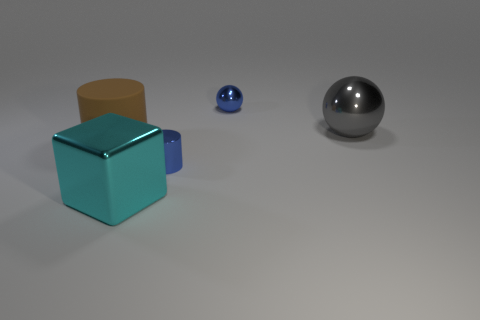Are any yellow metallic spheres visible?
Make the answer very short. No. What number of small objects are either cyan metal things or spheres?
Give a very brief answer. 1. Are there more tiny blue shiny cylinders to the left of the small blue shiny cylinder than large brown matte things that are behind the gray metallic sphere?
Make the answer very short. No. Is the material of the gray object the same as the cylinder to the right of the cyan metallic object?
Your answer should be compact. Yes. What is the color of the tiny metallic cylinder?
Your response must be concise. Blue. There is a tiny thing behind the large gray shiny ball; what shape is it?
Your answer should be compact. Sphere. What number of cyan objects are big objects or big matte objects?
Your answer should be very brief. 1. There is a small cylinder that is made of the same material as the big gray sphere; what color is it?
Your answer should be very brief. Blue. There is a big block; does it have the same color as the big thing behind the brown rubber thing?
Offer a very short reply. No. What is the color of the large object that is both on the right side of the large brown rubber object and in front of the big gray metallic ball?
Offer a terse response. Cyan. 